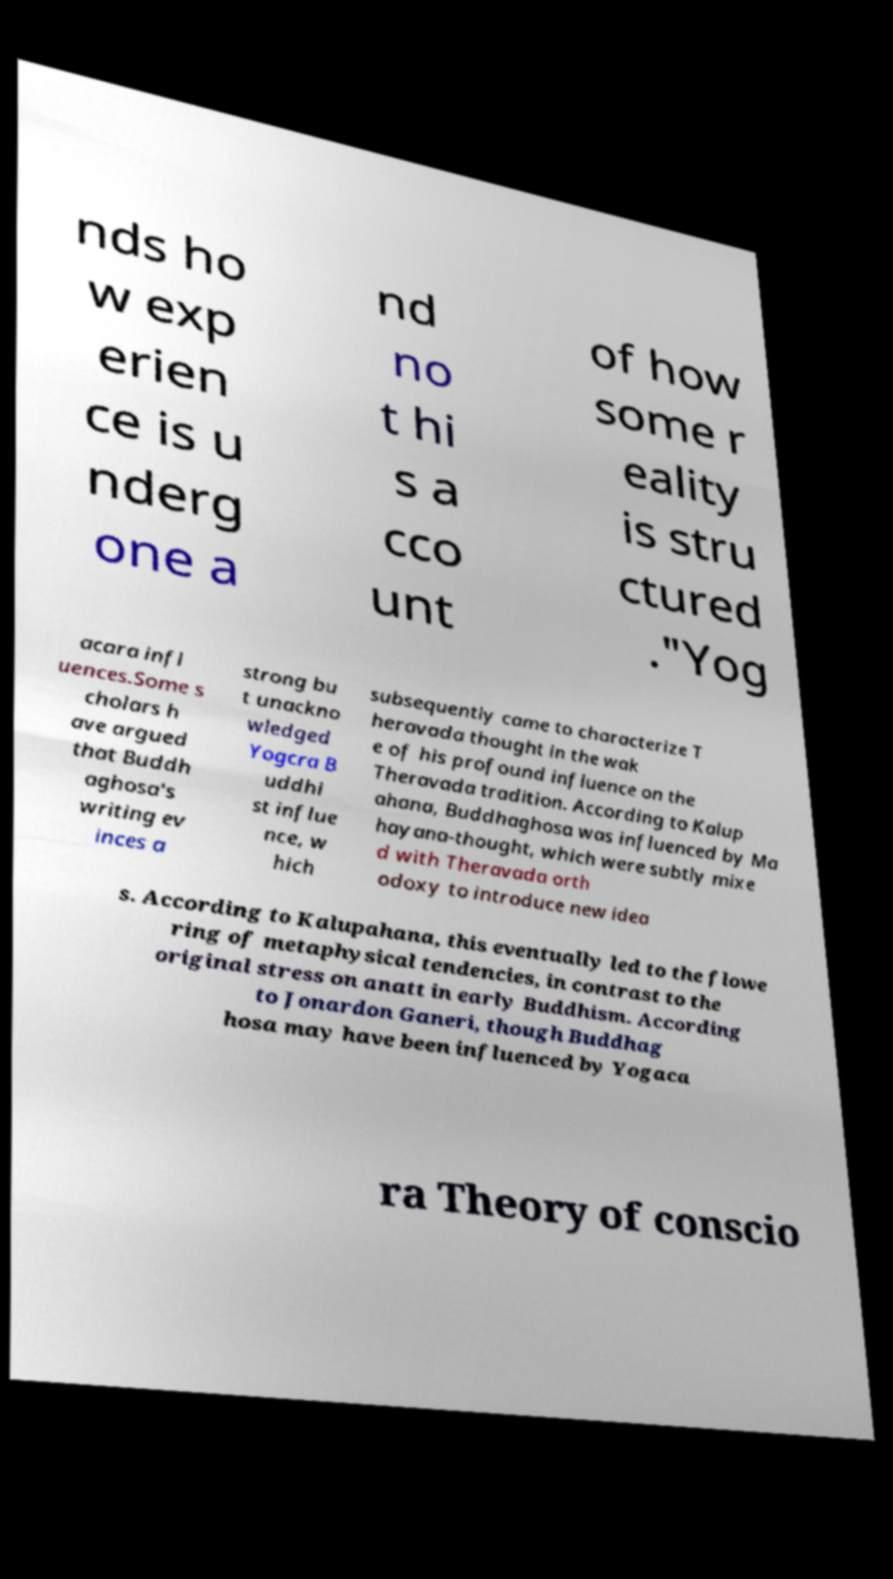Could you extract and type out the text from this image? nds ho w exp erien ce is u nderg one a nd no t hi s a cco unt of how some r eality is stru ctured ."Yog acara infl uences.Some s cholars h ave argued that Buddh aghosa's writing ev inces a strong bu t unackno wledged Yogcra B uddhi st influe nce, w hich subsequently came to characterize T heravada thought in the wak e of his profound influence on the Theravada tradition. According to Kalup ahana, Buddhaghosa was influenced by Ma hayana-thought, which were subtly mixe d with Theravada orth odoxy to introduce new idea s. According to Kalupahana, this eventually led to the flowe ring of metaphysical tendencies, in contrast to the original stress on anatt in early Buddhism. According to Jonardon Ganeri, though Buddhag hosa may have been influenced by Yogaca ra Theory of conscio 